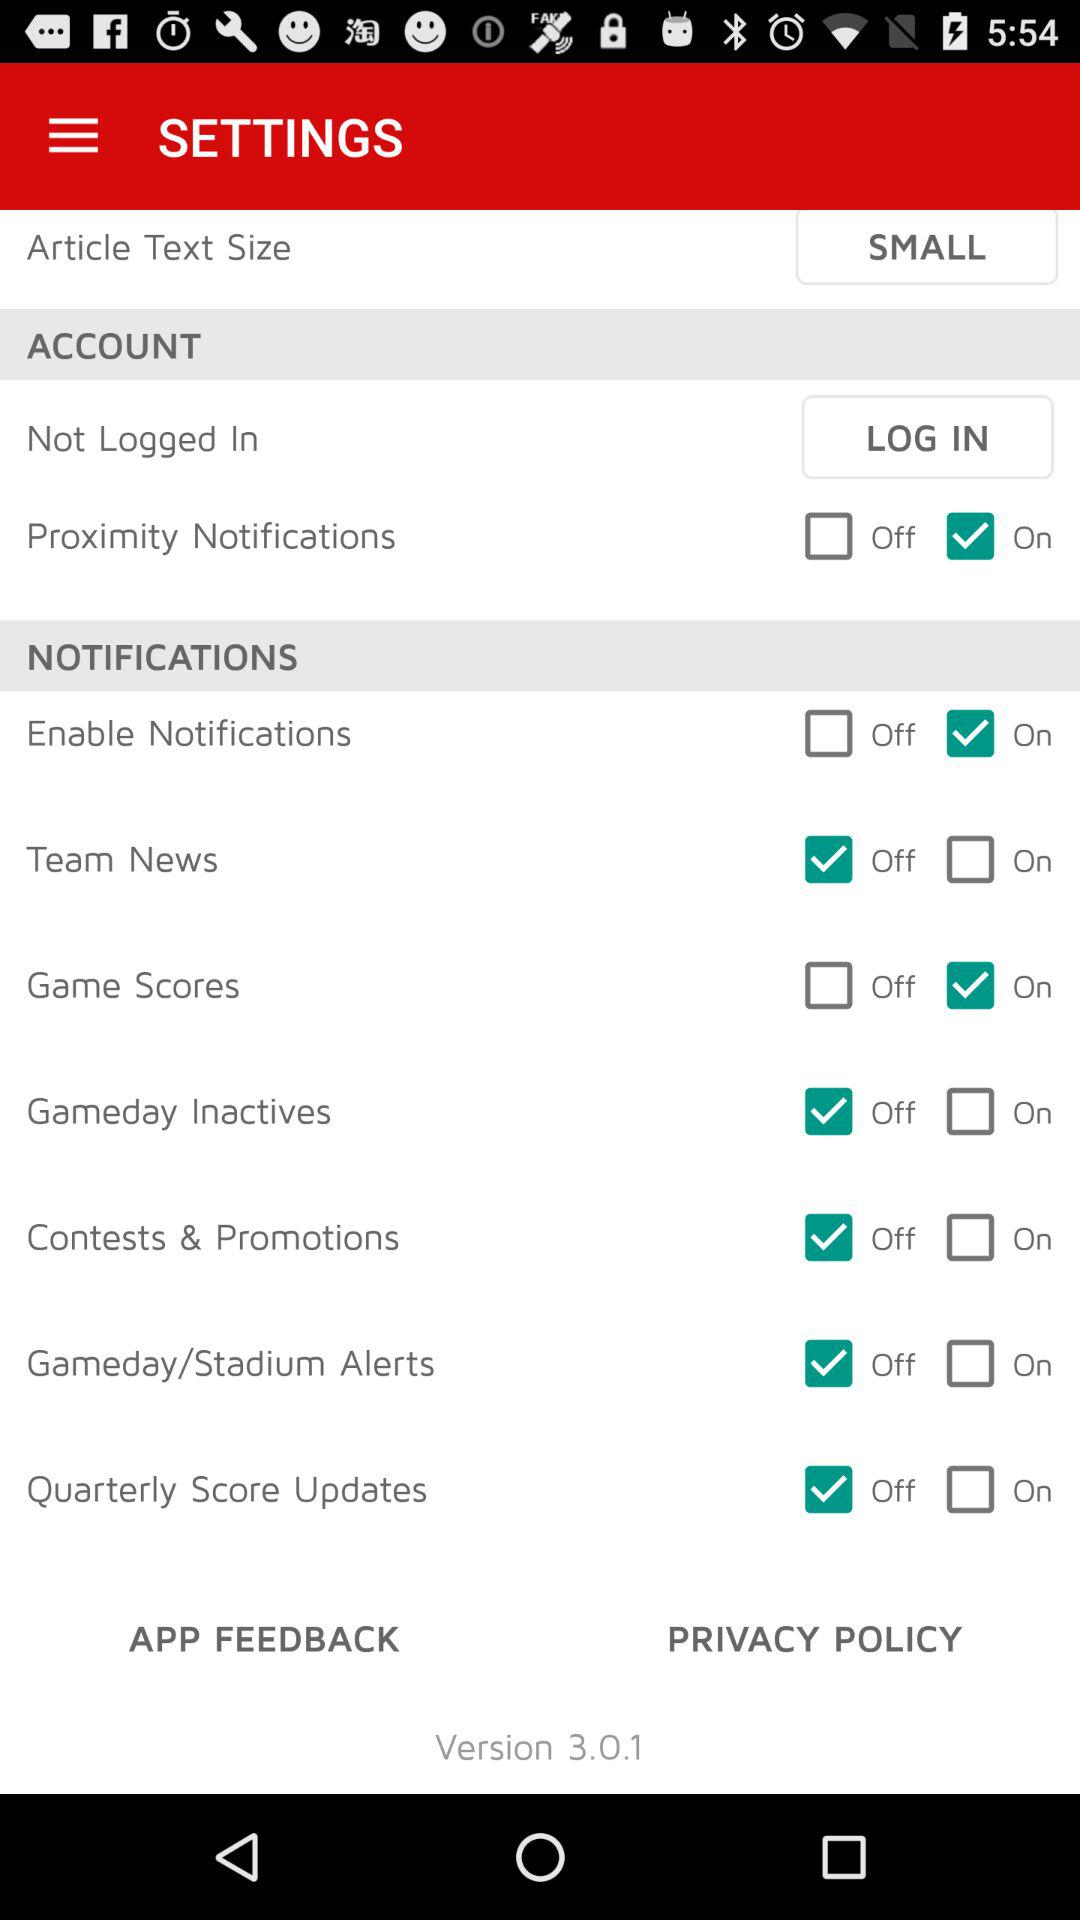What is the version? The version is 3.0.1. 